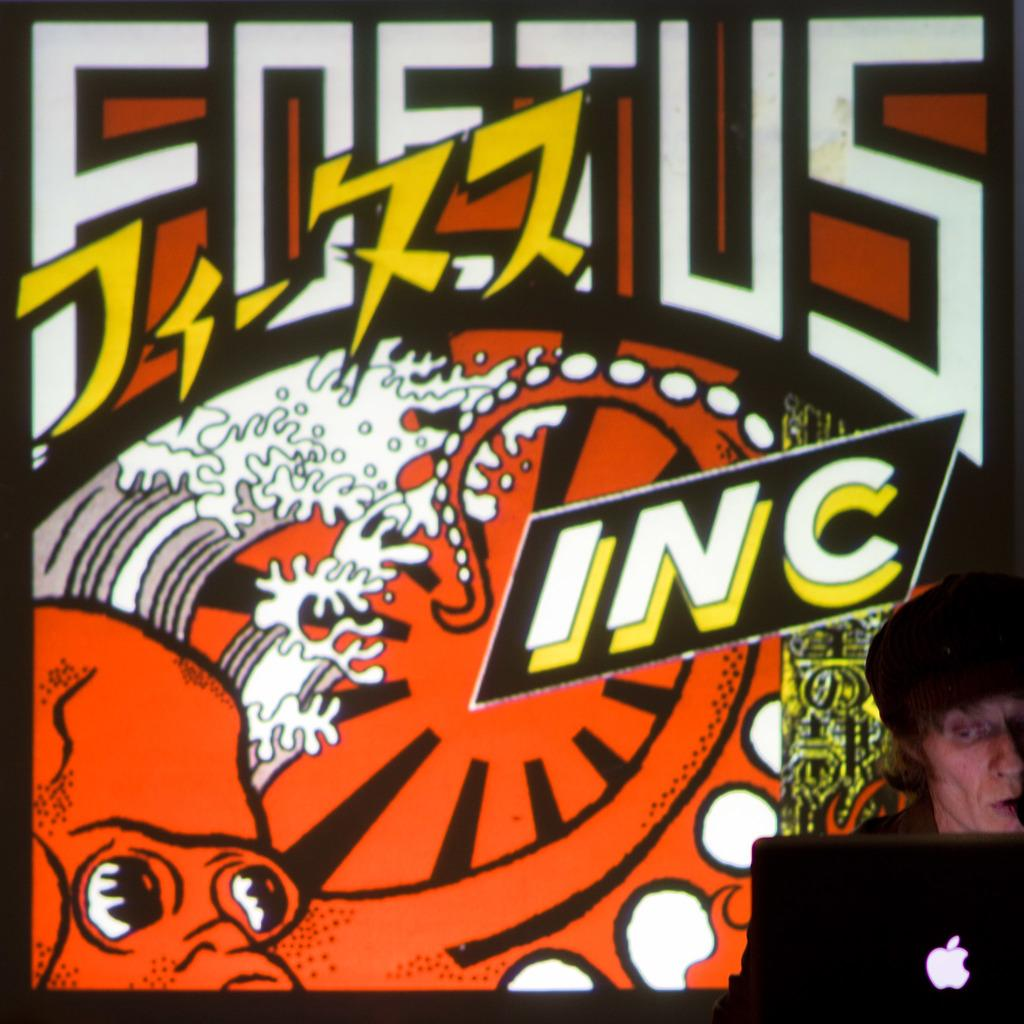Who or what is on the right side of the image? There is a person on the right side of the image. What is the person wearing on their head? The person is wearing a cap. What electronic device is present in the image? There is a laptop in the image. What can be seen in the background of the image? There is a board visible in the background of the image. What type of cactus is growing on the person's face in the image? There is no cactus growing on the person's face in the image. How much fuel is left in the laptop's battery in the image? The image does not provide information about the laptop's battery or fuel level. 